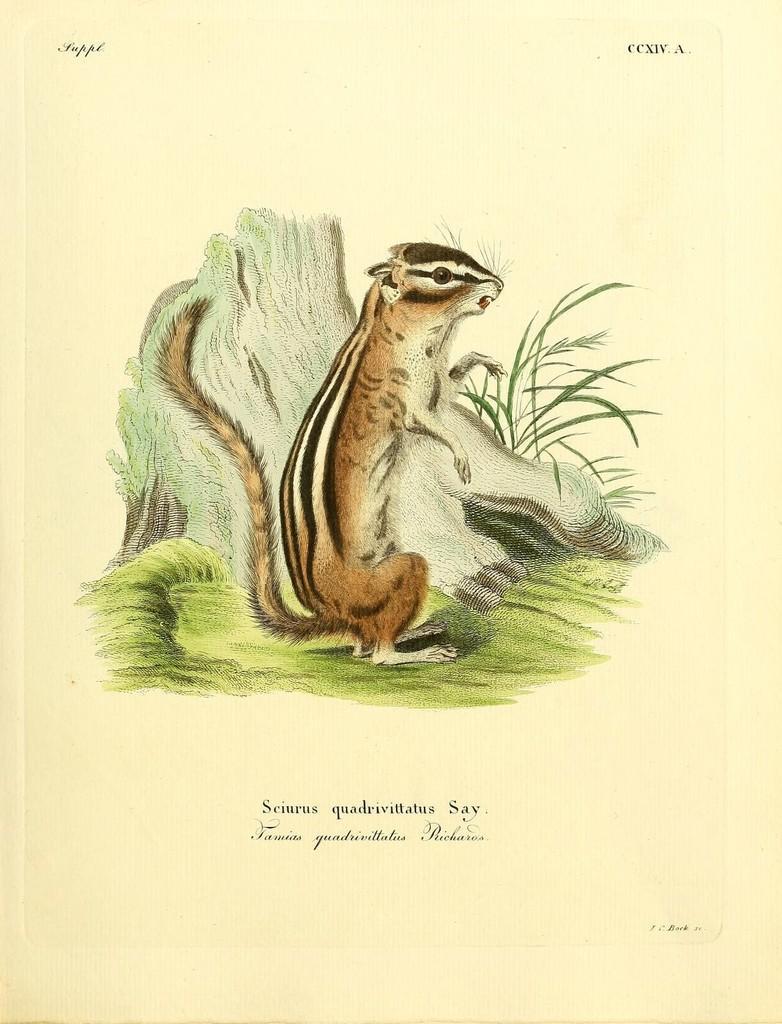How would you summarize this image in a sentence or two? This is a poster and in this poster we can see a squirrel standing on grass and some text. 